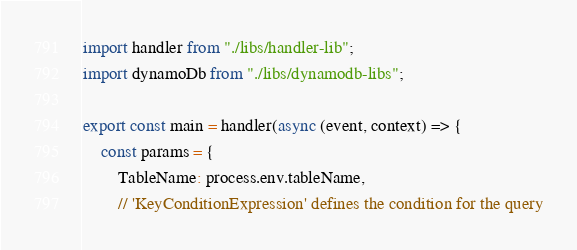Convert code to text. <code><loc_0><loc_0><loc_500><loc_500><_JavaScript_>import handler from "./libs/handler-lib";
import dynamoDb from "./libs/dynamodb-libs";

export const main = handler(async (event, context) => {
    const params = {
        TableName: process.env.tableName,
        // 'KeyConditionExpression' defines the condition for the query</code> 